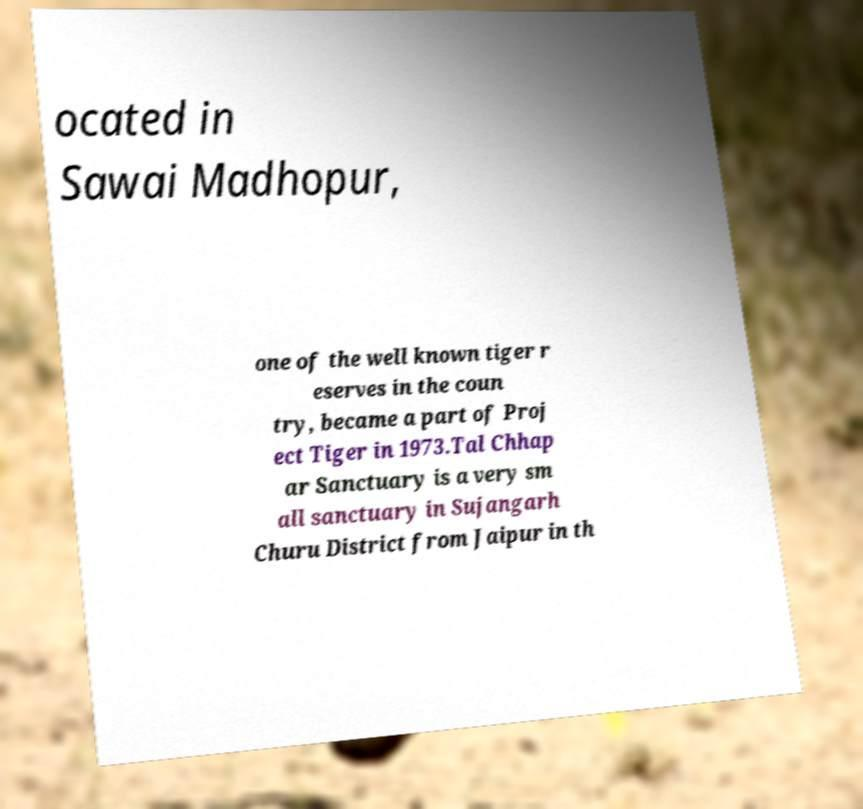Could you extract and type out the text from this image? ocated in Sawai Madhopur, one of the well known tiger r eserves in the coun try, became a part of Proj ect Tiger in 1973.Tal Chhap ar Sanctuary is a very sm all sanctuary in Sujangarh Churu District from Jaipur in th 